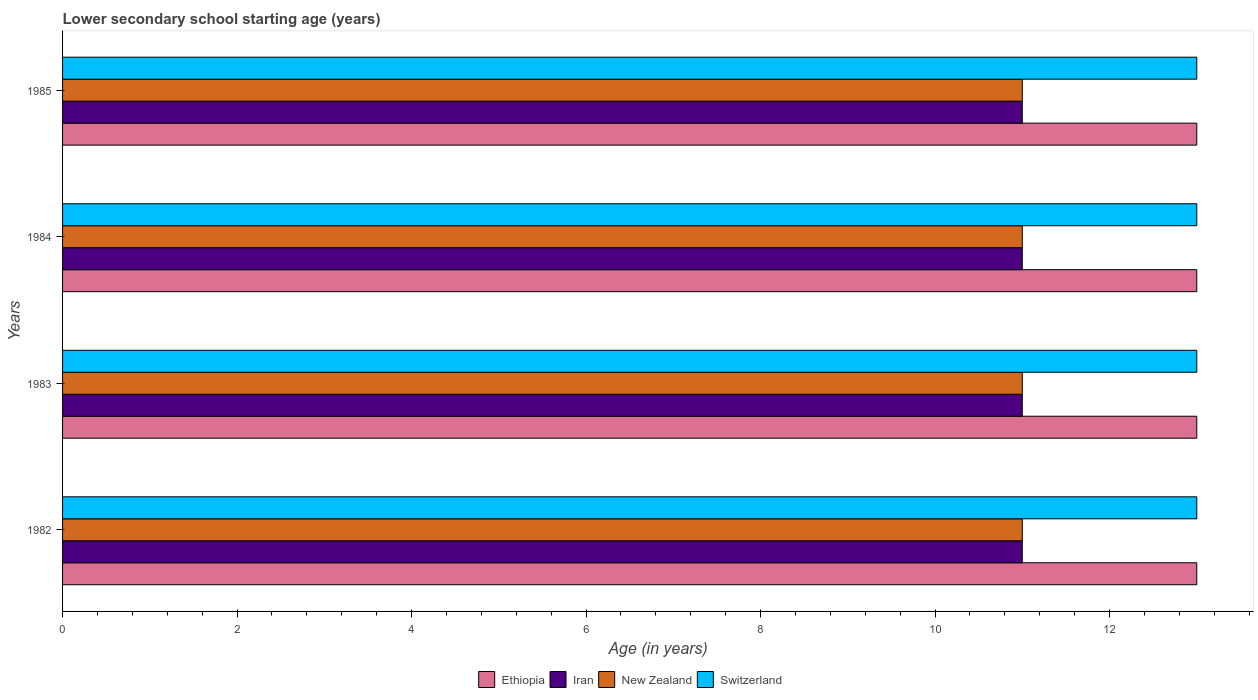Are the number of bars on each tick of the Y-axis equal?
Your answer should be very brief. Yes. How many bars are there on the 1st tick from the bottom?
Offer a terse response. 4. What is the label of the 3rd group of bars from the top?
Your answer should be very brief. 1983. What is the lower secondary school starting age of children in Iran in 1982?
Provide a succinct answer. 11. Across all years, what is the maximum lower secondary school starting age of children in Ethiopia?
Offer a very short reply. 13. Across all years, what is the minimum lower secondary school starting age of children in Ethiopia?
Provide a succinct answer. 13. In which year was the lower secondary school starting age of children in Switzerland maximum?
Provide a succinct answer. 1982. What is the total lower secondary school starting age of children in Switzerland in the graph?
Offer a very short reply. 52. What is the difference between the lower secondary school starting age of children in New Zealand in 1983 and that in 1984?
Make the answer very short. 0. What is the average lower secondary school starting age of children in Iran per year?
Your response must be concise. 11. In the year 1982, what is the difference between the lower secondary school starting age of children in Switzerland and lower secondary school starting age of children in New Zealand?
Make the answer very short. 2. What is the ratio of the lower secondary school starting age of children in Switzerland in 1983 to that in 1984?
Provide a succinct answer. 1. What is the difference between the highest and the second highest lower secondary school starting age of children in Ethiopia?
Give a very brief answer. 0. In how many years, is the lower secondary school starting age of children in Switzerland greater than the average lower secondary school starting age of children in Switzerland taken over all years?
Keep it short and to the point. 0. Is the sum of the lower secondary school starting age of children in Iran in 1983 and 1985 greater than the maximum lower secondary school starting age of children in Ethiopia across all years?
Your answer should be very brief. Yes. Is it the case that in every year, the sum of the lower secondary school starting age of children in Ethiopia and lower secondary school starting age of children in Iran is greater than the sum of lower secondary school starting age of children in Switzerland and lower secondary school starting age of children in New Zealand?
Offer a terse response. Yes. What does the 1st bar from the top in 1985 represents?
Provide a short and direct response. Switzerland. What does the 1st bar from the bottom in 1983 represents?
Your answer should be very brief. Ethiopia. Is it the case that in every year, the sum of the lower secondary school starting age of children in Iran and lower secondary school starting age of children in New Zealand is greater than the lower secondary school starting age of children in Ethiopia?
Your answer should be compact. Yes. Are all the bars in the graph horizontal?
Offer a very short reply. Yes. What is the title of the graph?
Ensure brevity in your answer.  Lower secondary school starting age (years). What is the label or title of the X-axis?
Your response must be concise. Age (in years). What is the Age (in years) in Iran in 1982?
Your answer should be very brief. 11. What is the Age (in years) in New Zealand in 1982?
Offer a terse response. 11. What is the Age (in years) in Switzerland in 1982?
Give a very brief answer. 13. What is the Age (in years) in New Zealand in 1983?
Provide a succinct answer. 11. What is the Age (in years) in Switzerland in 1983?
Make the answer very short. 13. What is the Age (in years) in Ethiopia in 1984?
Offer a terse response. 13. What is the Age (in years) of Iran in 1984?
Keep it short and to the point. 11. What is the Age (in years) in New Zealand in 1984?
Offer a very short reply. 11. What is the Age (in years) of New Zealand in 1985?
Ensure brevity in your answer.  11. What is the Age (in years) of Switzerland in 1985?
Give a very brief answer. 13. Across all years, what is the maximum Age (in years) of Iran?
Provide a succinct answer. 11. Across all years, what is the maximum Age (in years) in Switzerland?
Make the answer very short. 13. Across all years, what is the minimum Age (in years) in Ethiopia?
Offer a very short reply. 13. What is the total Age (in years) in Iran in the graph?
Give a very brief answer. 44. What is the total Age (in years) of New Zealand in the graph?
Make the answer very short. 44. What is the difference between the Age (in years) of Switzerland in 1982 and that in 1983?
Ensure brevity in your answer.  0. What is the difference between the Age (in years) in Ethiopia in 1982 and that in 1984?
Your response must be concise. 0. What is the difference between the Age (in years) of Iran in 1982 and that in 1984?
Offer a very short reply. 0. What is the difference between the Age (in years) of Ethiopia in 1982 and that in 1985?
Offer a terse response. 0. What is the difference between the Age (in years) in New Zealand in 1982 and that in 1985?
Keep it short and to the point. 0. What is the difference between the Age (in years) in Switzerland in 1982 and that in 1985?
Ensure brevity in your answer.  0. What is the difference between the Age (in years) in Iran in 1983 and that in 1984?
Ensure brevity in your answer.  0. What is the difference between the Age (in years) of Iran in 1983 and that in 1985?
Your answer should be very brief. 0. What is the difference between the Age (in years) of New Zealand in 1983 and that in 1985?
Give a very brief answer. 0. What is the difference between the Age (in years) in Ethiopia in 1984 and that in 1985?
Give a very brief answer. 0. What is the difference between the Age (in years) of Ethiopia in 1982 and the Age (in years) of Iran in 1983?
Ensure brevity in your answer.  2. What is the difference between the Age (in years) of Iran in 1982 and the Age (in years) of New Zealand in 1983?
Ensure brevity in your answer.  0. What is the difference between the Age (in years) of Iran in 1982 and the Age (in years) of Switzerland in 1983?
Offer a terse response. -2. What is the difference between the Age (in years) in New Zealand in 1982 and the Age (in years) in Switzerland in 1983?
Provide a succinct answer. -2. What is the difference between the Age (in years) of Ethiopia in 1982 and the Age (in years) of New Zealand in 1984?
Ensure brevity in your answer.  2. What is the difference between the Age (in years) in Iran in 1982 and the Age (in years) in Switzerland in 1984?
Offer a terse response. -2. What is the difference between the Age (in years) of Ethiopia in 1982 and the Age (in years) of Switzerland in 1985?
Provide a short and direct response. 0. What is the difference between the Age (in years) in Iran in 1982 and the Age (in years) in New Zealand in 1985?
Offer a very short reply. 0. What is the difference between the Age (in years) in New Zealand in 1982 and the Age (in years) in Switzerland in 1985?
Your response must be concise. -2. What is the difference between the Age (in years) in Ethiopia in 1983 and the Age (in years) in New Zealand in 1984?
Keep it short and to the point. 2. What is the difference between the Age (in years) of Ethiopia in 1983 and the Age (in years) of Switzerland in 1984?
Give a very brief answer. 0. What is the difference between the Age (in years) of New Zealand in 1983 and the Age (in years) of Switzerland in 1984?
Ensure brevity in your answer.  -2. What is the difference between the Age (in years) of Ethiopia in 1983 and the Age (in years) of Iran in 1985?
Keep it short and to the point. 2. What is the difference between the Age (in years) of Ethiopia in 1983 and the Age (in years) of Switzerland in 1985?
Your answer should be very brief. 0. What is the difference between the Age (in years) in New Zealand in 1983 and the Age (in years) in Switzerland in 1985?
Your response must be concise. -2. What is the difference between the Age (in years) in Ethiopia in 1984 and the Age (in years) in Iran in 1985?
Provide a short and direct response. 2. What is the difference between the Age (in years) of Ethiopia in 1984 and the Age (in years) of New Zealand in 1985?
Your answer should be compact. 2. What is the difference between the Age (in years) of Iran in 1984 and the Age (in years) of New Zealand in 1985?
Your answer should be very brief. 0. What is the difference between the Age (in years) of Iran in 1984 and the Age (in years) of Switzerland in 1985?
Provide a short and direct response. -2. What is the difference between the Age (in years) of New Zealand in 1984 and the Age (in years) of Switzerland in 1985?
Keep it short and to the point. -2. In the year 1982, what is the difference between the Age (in years) in Ethiopia and Age (in years) in Iran?
Keep it short and to the point. 2. In the year 1982, what is the difference between the Age (in years) in Ethiopia and Age (in years) in New Zealand?
Keep it short and to the point. 2. In the year 1982, what is the difference between the Age (in years) in Ethiopia and Age (in years) in Switzerland?
Ensure brevity in your answer.  0. In the year 1982, what is the difference between the Age (in years) of Iran and Age (in years) of New Zealand?
Give a very brief answer. 0. In the year 1982, what is the difference between the Age (in years) of Iran and Age (in years) of Switzerland?
Give a very brief answer. -2. In the year 1982, what is the difference between the Age (in years) of New Zealand and Age (in years) of Switzerland?
Offer a terse response. -2. In the year 1983, what is the difference between the Age (in years) in Ethiopia and Age (in years) in Iran?
Provide a succinct answer. 2. In the year 1983, what is the difference between the Age (in years) of Ethiopia and Age (in years) of Switzerland?
Offer a terse response. 0. In the year 1983, what is the difference between the Age (in years) in Iran and Age (in years) in New Zealand?
Ensure brevity in your answer.  0. In the year 1983, what is the difference between the Age (in years) in Iran and Age (in years) in Switzerland?
Your answer should be compact. -2. In the year 1983, what is the difference between the Age (in years) in New Zealand and Age (in years) in Switzerland?
Your response must be concise. -2. In the year 1984, what is the difference between the Age (in years) in Ethiopia and Age (in years) in Switzerland?
Ensure brevity in your answer.  0. In the year 1984, what is the difference between the Age (in years) of Iran and Age (in years) of New Zealand?
Your answer should be compact. 0. In the year 1984, what is the difference between the Age (in years) in Iran and Age (in years) in Switzerland?
Keep it short and to the point. -2. In the year 1984, what is the difference between the Age (in years) in New Zealand and Age (in years) in Switzerland?
Offer a very short reply. -2. In the year 1985, what is the difference between the Age (in years) of Ethiopia and Age (in years) of Switzerland?
Provide a succinct answer. 0. In the year 1985, what is the difference between the Age (in years) of New Zealand and Age (in years) of Switzerland?
Your answer should be very brief. -2. What is the ratio of the Age (in years) in Switzerland in 1982 to that in 1983?
Provide a succinct answer. 1. What is the ratio of the Age (in years) of Switzerland in 1982 to that in 1984?
Your answer should be very brief. 1. What is the ratio of the Age (in years) in New Zealand in 1982 to that in 1985?
Provide a short and direct response. 1. What is the ratio of the Age (in years) of Ethiopia in 1983 to that in 1984?
Give a very brief answer. 1. What is the ratio of the Age (in years) of Iran in 1983 to that in 1984?
Your answer should be compact. 1. What is the ratio of the Age (in years) of New Zealand in 1983 to that in 1984?
Give a very brief answer. 1. What is the ratio of the Age (in years) of Switzerland in 1983 to that in 1984?
Give a very brief answer. 1. What is the ratio of the Age (in years) of Ethiopia in 1983 to that in 1985?
Your response must be concise. 1. What is the ratio of the Age (in years) of Ethiopia in 1984 to that in 1985?
Provide a short and direct response. 1. What is the ratio of the Age (in years) of Iran in 1984 to that in 1985?
Provide a succinct answer. 1. What is the difference between the highest and the second highest Age (in years) of New Zealand?
Ensure brevity in your answer.  0. What is the difference between the highest and the lowest Age (in years) of New Zealand?
Provide a succinct answer. 0. What is the difference between the highest and the lowest Age (in years) of Switzerland?
Provide a short and direct response. 0. 